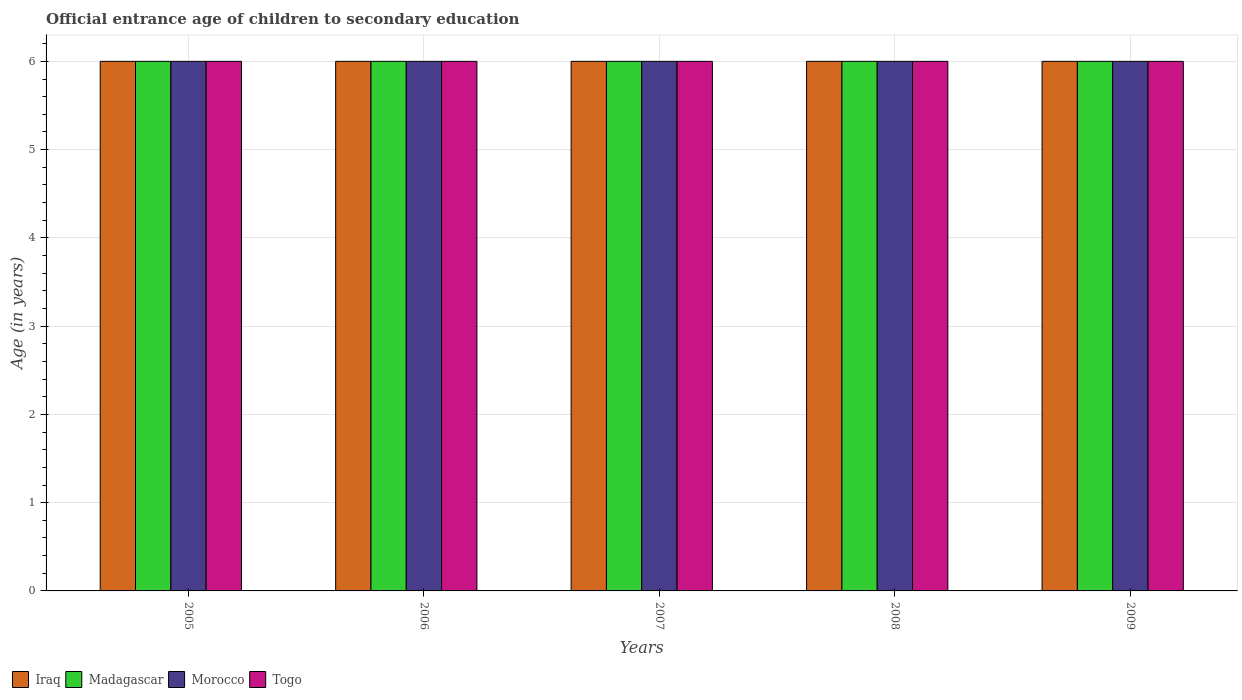Are the number of bars per tick equal to the number of legend labels?
Make the answer very short. Yes. Are the number of bars on each tick of the X-axis equal?
Your answer should be very brief. Yes. What is the label of the 4th group of bars from the left?
Ensure brevity in your answer.  2008. In how many cases, is the number of bars for a given year not equal to the number of legend labels?
Keep it short and to the point. 0. Across all years, what is the maximum secondary school starting age of children in Madagascar?
Your answer should be very brief. 6. In which year was the secondary school starting age of children in Togo maximum?
Keep it short and to the point. 2005. In which year was the secondary school starting age of children in Morocco minimum?
Keep it short and to the point. 2005. What is the total secondary school starting age of children in Morocco in the graph?
Ensure brevity in your answer.  30. What is the difference between the secondary school starting age of children in Iraq in 2005 and that in 2008?
Provide a short and direct response. 0. In how many years, is the secondary school starting age of children in Togo greater than 5.2 years?
Your answer should be compact. 5. What is the ratio of the secondary school starting age of children in Madagascar in 2007 to that in 2008?
Provide a short and direct response. 1. Is the secondary school starting age of children in Togo in 2006 less than that in 2007?
Offer a very short reply. No. What is the difference between the highest and the lowest secondary school starting age of children in Togo?
Provide a short and direct response. 0. Is the sum of the secondary school starting age of children in Madagascar in 2007 and 2009 greater than the maximum secondary school starting age of children in Iraq across all years?
Give a very brief answer. Yes. What does the 4th bar from the left in 2008 represents?
Offer a very short reply. Togo. What does the 1st bar from the right in 2009 represents?
Offer a very short reply. Togo. Are all the bars in the graph horizontal?
Your answer should be very brief. No. How many years are there in the graph?
Give a very brief answer. 5. How many legend labels are there?
Your answer should be very brief. 4. What is the title of the graph?
Provide a short and direct response. Official entrance age of children to secondary education. Does "Cote d'Ivoire" appear as one of the legend labels in the graph?
Provide a succinct answer. No. What is the label or title of the X-axis?
Provide a short and direct response. Years. What is the label or title of the Y-axis?
Your response must be concise. Age (in years). What is the Age (in years) of Iraq in 2005?
Give a very brief answer. 6. What is the Age (in years) of Madagascar in 2005?
Your answer should be compact. 6. What is the Age (in years) of Morocco in 2005?
Your answer should be very brief. 6. What is the Age (in years) of Madagascar in 2006?
Your answer should be very brief. 6. What is the Age (in years) in Togo in 2006?
Your answer should be compact. 6. What is the Age (in years) of Madagascar in 2007?
Offer a very short reply. 6. What is the Age (in years) of Morocco in 2007?
Your answer should be compact. 6. What is the Age (in years) of Iraq in 2008?
Ensure brevity in your answer.  6. What is the Age (in years) of Madagascar in 2008?
Provide a short and direct response. 6. What is the Age (in years) of Morocco in 2008?
Make the answer very short. 6. What is the Age (in years) in Togo in 2008?
Provide a short and direct response. 6. What is the Age (in years) in Morocco in 2009?
Give a very brief answer. 6. What is the Age (in years) of Togo in 2009?
Your answer should be compact. 6. Across all years, what is the minimum Age (in years) in Iraq?
Ensure brevity in your answer.  6. Across all years, what is the minimum Age (in years) of Madagascar?
Provide a short and direct response. 6. Across all years, what is the minimum Age (in years) of Morocco?
Your answer should be very brief. 6. What is the total Age (in years) of Morocco in the graph?
Keep it short and to the point. 30. What is the difference between the Age (in years) in Madagascar in 2005 and that in 2006?
Keep it short and to the point. 0. What is the difference between the Age (in years) of Iraq in 2005 and that in 2007?
Provide a short and direct response. 0. What is the difference between the Age (in years) in Togo in 2005 and that in 2007?
Offer a very short reply. 0. What is the difference between the Age (in years) of Iraq in 2005 and that in 2008?
Provide a short and direct response. 0. What is the difference between the Age (in years) in Madagascar in 2005 and that in 2008?
Keep it short and to the point. 0. What is the difference between the Age (in years) of Morocco in 2005 and that in 2008?
Your answer should be very brief. 0. What is the difference between the Age (in years) in Togo in 2005 and that in 2008?
Ensure brevity in your answer.  0. What is the difference between the Age (in years) of Morocco in 2005 and that in 2009?
Offer a terse response. 0. What is the difference between the Age (in years) in Togo in 2005 and that in 2009?
Keep it short and to the point. 0. What is the difference between the Age (in years) of Morocco in 2006 and that in 2007?
Your response must be concise. 0. What is the difference between the Age (in years) of Togo in 2006 and that in 2007?
Provide a succinct answer. 0. What is the difference between the Age (in years) of Morocco in 2006 and that in 2008?
Provide a succinct answer. 0. What is the difference between the Age (in years) of Togo in 2006 and that in 2009?
Offer a very short reply. 0. What is the difference between the Age (in years) of Iraq in 2007 and that in 2009?
Your response must be concise. 0. What is the difference between the Age (in years) in Madagascar in 2007 and that in 2009?
Make the answer very short. 0. What is the difference between the Age (in years) in Togo in 2007 and that in 2009?
Your response must be concise. 0. What is the difference between the Age (in years) of Morocco in 2008 and that in 2009?
Make the answer very short. 0. What is the difference between the Age (in years) in Madagascar in 2005 and the Age (in years) in Morocco in 2006?
Provide a short and direct response. 0. What is the difference between the Age (in years) in Morocco in 2005 and the Age (in years) in Togo in 2006?
Make the answer very short. 0. What is the difference between the Age (in years) in Iraq in 2005 and the Age (in years) in Madagascar in 2007?
Offer a terse response. 0. What is the difference between the Age (in years) of Iraq in 2005 and the Age (in years) of Morocco in 2007?
Keep it short and to the point. 0. What is the difference between the Age (in years) in Iraq in 2005 and the Age (in years) in Togo in 2007?
Your answer should be compact. 0. What is the difference between the Age (in years) in Madagascar in 2005 and the Age (in years) in Togo in 2007?
Make the answer very short. 0. What is the difference between the Age (in years) in Iraq in 2005 and the Age (in years) in Madagascar in 2008?
Give a very brief answer. 0. What is the difference between the Age (in years) of Iraq in 2005 and the Age (in years) of Morocco in 2008?
Provide a succinct answer. 0. What is the difference between the Age (in years) of Madagascar in 2005 and the Age (in years) of Togo in 2008?
Offer a very short reply. 0. What is the difference between the Age (in years) in Iraq in 2005 and the Age (in years) in Morocco in 2009?
Provide a short and direct response. 0. What is the difference between the Age (in years) of Iraq in 2005 and the Age (in years) of Togo in 2009?
Your answer should be very brief. 0. What is the difference between the Age (in years) of Madagascar in 2005 and the Age (in years) of Morocco in 2009?
Make the answer very short. 0. What is the difference between the Age (in years) in Madagascar in 2005 and the Age (in years) in Togo in 2009?
Keep it short and to the point. 0. What is the difference between the Age (in years) in Iraq in 2006 and the Age (in years) in Madagascar in 2007?
Provide a short and direct response. 0. What is the difference between the Age (in years) of Iraq in 2006 and the Age (in years) of Morocco in 2007?
Offer a very short reply. 0. What is the difference between the Age (in years) in Iraq in 2006 and the Age (in years) in Togo in 2007?
Provide a succinct answer. 0. What is the difference between the Age (in years) in Iraq in 2006 and the Age (in years) in Madagascar in 2008?
Offer a very short reply. 0. What is the difference between the Age (in years) of Iraq in 2006 and the Age (in years) of Morocco in 2008?
Offer a terse response. 0. What is the difference between the Age (in years) in Morocco in 2006 and the Age (in years) in Togo in 2008?
Ensure brevity in your answer.  0. What is the difference between the Age (in years) in Iraq in 2006 and the Age (in years) in Madagascar in 2009?
Keep it short and to the point. 0. What is the difference between the Age (in years) of Iraq in 2006 and the Age (in years) of Morocco in 2009?
Your answer should be compact. 0. What is the difference between the Age (in years) in Iraq in 2006 and the Age (in years) in Togo in 2009?
Offer a very short reply. 0. What is the difference between the Age (in years) of Madagascar in 2006 and the Age (in years) of Morocco in 2009?
Ensure brevity in your answer.  0. What is the difference between the Age (in years) of Madagascar in 2006 and the Age (in years) of Togo in 2009?
Offer a very short reply. 0. What is the difference between the Age (in years) of Morocco in 2006 and the Age (in years) of Togo in 2009?
Your answer should be very brief. 0. What is the difference between the Age (in years) in Iraq in 2007 and the Age (in years) in Morocco in 2008?
Provide a succinct answer. 0. What is the difference between the Age (in years) in Madagascar in 2007 and the Age (in years) in Morocco in 2008?
Provide a succinct answer. 0. What is the difference between the Age (in years) of Morocco in 2007 and the Age (in years) of Togo in 2009?
Keep it short and to the point. 0. What is the difference between the Age (in years) of Iraq in 2008 and the Age (in years) of Morocco in 2009?
Your answer should be very brief. 0. What is the difference between the Age (in years) in Iraq in 2008 and the Age (in years) in Togo in 2009?
Your response must be concise. 0. What is the difference between the Age (in years) in Madagascar in 2008 and the Age (in years) in Morocco in 2009?
Keep it short and to the point. 0. What is the difference between the Age (in years) of Madagascar in 2008 and the Age (in years) of Togo in 2009?
Your response must be concise. 0. What is the difference between the Age (in years) of Morocco in 2008 and the Age (in years) of Togo in 2009?
Provide a succinct answer. 0. What is the average Age (in years) of Madagascar per year?
Your answer should be compact. 6. In the year 2005, what is the difference between the Age (in years) in Iraq and Age (in years) in Togo?
Your response must be concise. 0. In the year 2005, what is the difference between the Age (in years) of Morocco and Age (in years) of Togo?
Offer a very short reply. 0. In the year 2006, what is the difference between the Age (in years) of Madagascar and Age (in years) of Togo?
Your response must be concise. 0. In the year 2007, what is the difference between the Age (in years) of Iraq and Age (in years) of Madagascar?
Provide a short and direct response. 0. In the year 2007, what is the difference between the Age (in years) in Iraq and Age (in years) in Morocco?
Ensure brevity in your answer.  0. In the year 2007, what is the difference between the Age (in years) of Iraq and Age (in years) of Togo?
Offer a very short reply. 0. In the year 2007, what is the difference between the Age (in years) in Madagascar and Age (in years) in Morocco?
Give a very brief answer. 0. In the year 2007, what is the difference between the Age (in years) of Madagascar and Age (in years) of Togo?
Give a very brief answer. 0. In the year 2007, what is the difference between the Age (in years) in Morocco and Age (in years) in Togo?
Offer a very short reply. 0. In the year 2008, what is the difference between the Age (in years) of Madagascar and Age (in years) of Morocco?
Offer a terse response. 0. In the year 2008, what is the difference between the Age (in years) in Morocco and Age (in years) in Togo?
Make the answer very short. 0. In the year 2009, what is the difference between the Age (in years) in Iraq and Age (in years) in Morocco?
Ensure brevity in your answer.  0. In the year 2009, what is the difference between the Age (in years) of Morocco and Age (in years) of Togo?
Your answer should be very brief. 0. What is the ratio of the Age (in years) of Madagascar in 2005 to that in 2006?
Your answer should be compact. 1. What is the ratio of the Age (in years) of Morocco in 2005 to that in 2006?
Offer a terse response. 1. What is the ratio of the Age (in years) of Togo in 2005 to that in 2006?
Make the answer very short. 1. What is the ratio of the Age (in years) in Iraq in 2005 to that in 2007?
Give a very brief answer. 1. What is the ratio of the Age (in years) of Madagascar in 2005 to that in 2007?
Your response must be concise. 1. What is the ratio of the Age (in years) of Madagascar in 2005 to that in 2008?
Make the answer very short. 1. What is the ratio of the Age (in years) of Morocco in 2005 to that in 2008?
Your response must be concise. 1. What is the ratio of the Age (in years) of Togo in 2005 to that in 2008?
Make the answer very short. 1. What is the ratio of the Age (in years) of Iraq in 2005 to that in 2009?
Give a very brief answer. 1. What is the ratio of the Age (in years) of Madagascar in 2006 to that in 2007?
Your answer should be very brief. 1. What is the ratio of the Age (in years) of Iraq in 2006 to that in 2008?
Your answer should be very brief. 1. What is the ratio of the Age (in years) of Madagascar in 2006 to that in 2008?
Ensure brevity in your answer.  1. What is the ratio of the Age (in years) in Togo in 2006 to that in 2008?
Offer a very short reply. 1. What is the ratio of the Age (in years) in Iraq in 2006 to that in 2009?
Your answer should be compact. 1. What is the ratio of the Age (in years) in Madagascar in 2006 to that in 2009?
Provide a short and direct response. 1. What is the ratio of the Age (in years) of Morocco in 2006 to that in 2009?
Offer a very short reply. 1. What is the ratio of the Age (in years) in Togo in 2006 to that in 2009?
Your answer should be very brief. 1. What is the ratio of the Age (in years) of Morocco in 2007 to that in 2008?
Offer a very short reply. 1. What is the ratio of the Age (in years) of Togo in 2007 to that in 2008?
Your answer should be very brief. 1. What is the ratio of the Age (in years) of Iraq in 2007 to that in 2009?
Make the answer very short. 1. What is the ratio of the Age (in years) of Togo in 2007 to that in 2009?
Ensure brevity in your answer.  1. What is the ratio of the Age (in years) of Iraq in 2008 to that in 2009?
Offer a terse response. 1. What is the ratio of the Age (in years) of Togo in 2008 to that in 2009?
Provide a short and direct response. 1. What is the difference between the highest and the second highest Age (in years) of Morocco?
Your answer should be compact. 0. 